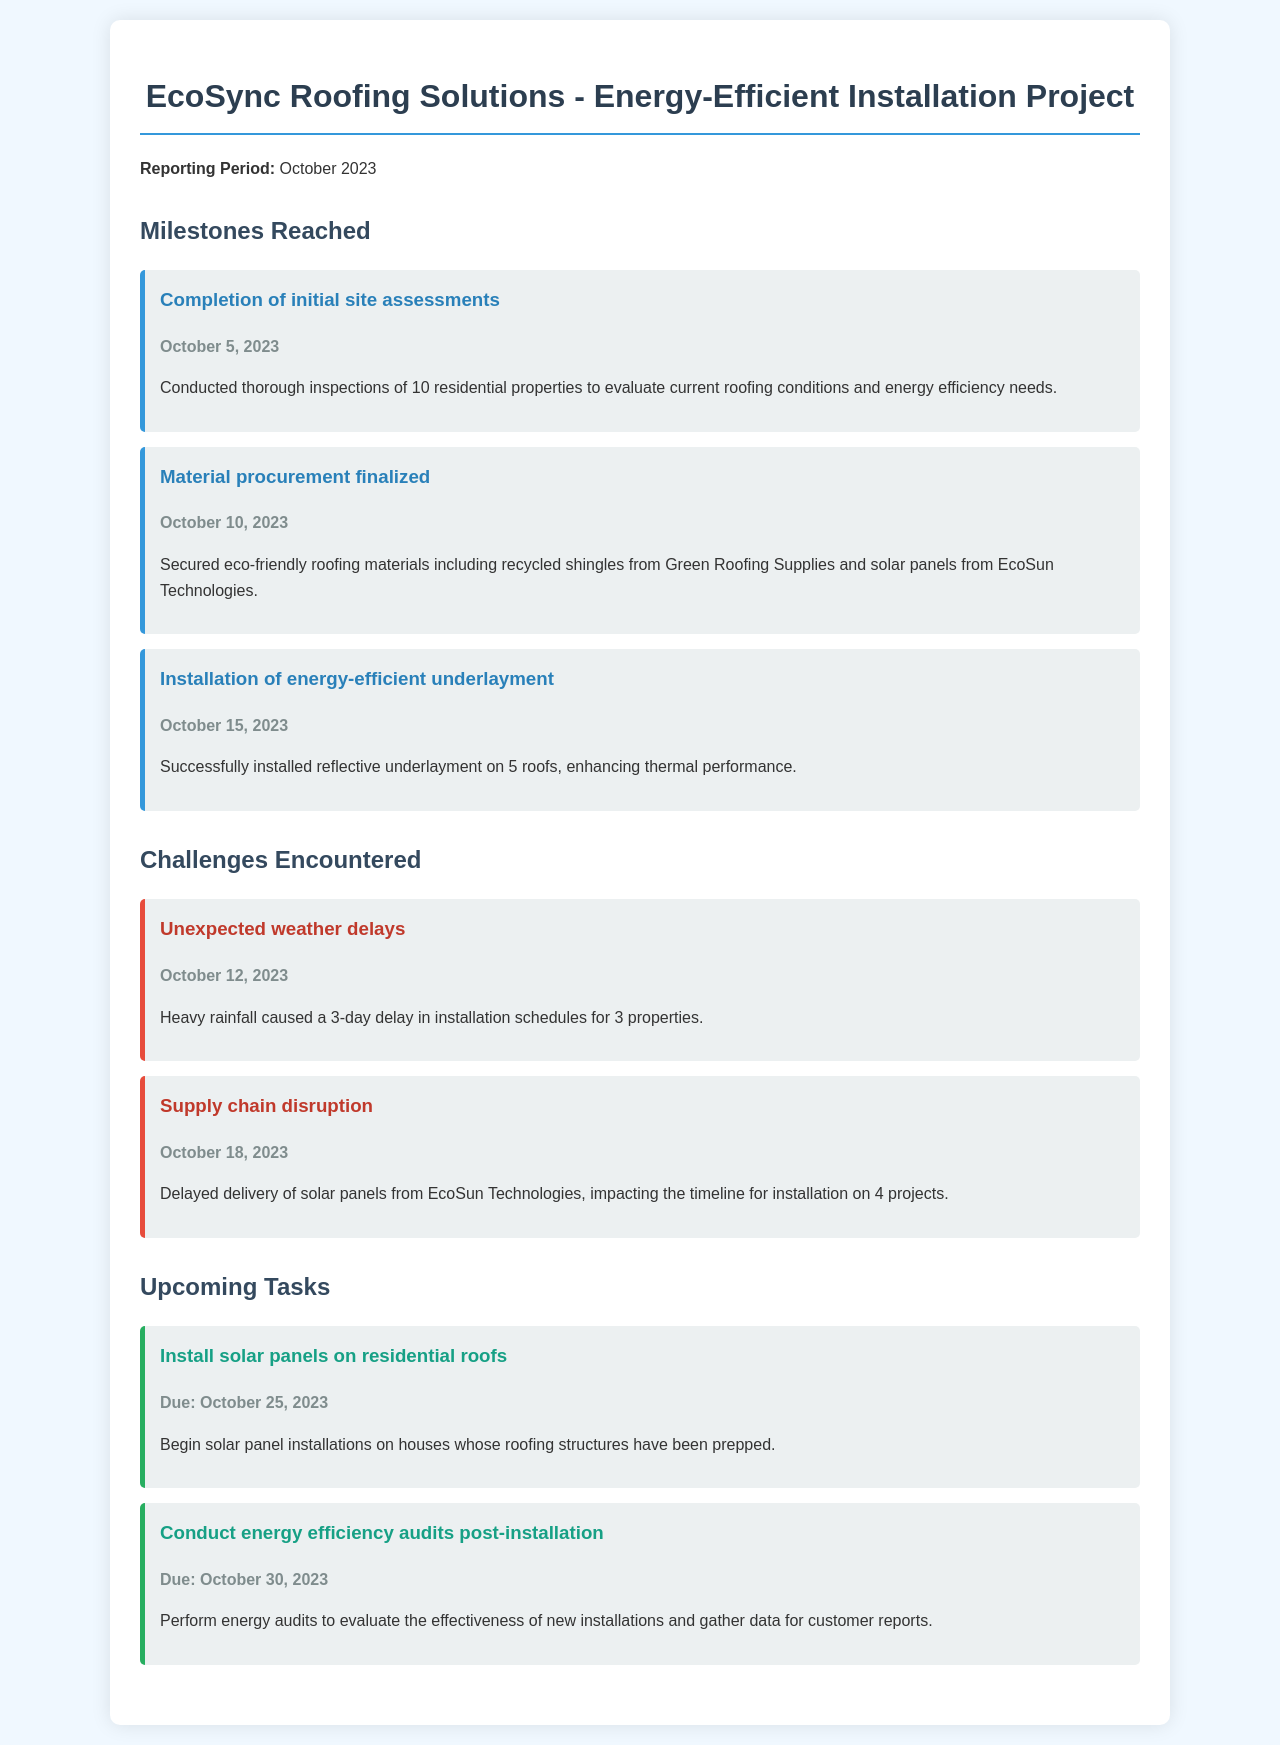What is the reporting period? The reporting period is specified in the document as October 2023.
Answer: October 2023 How many residential properties were inspected? The document states that inspections were conducted on 10 residential properties.
Answer: 10 What material was secured from Green Roofing Supplies? The document mentions that recycled shingles were procured from Green Roofing Supplies.
Answer: Recycled shingles What challenge caused a 3-day delay? The document notes that heavy rainfall caused a 3-day delay in installation schedules.
Answer: Heavy rainfall What is the due date for solar panel installations? The document provides a due date for solar panel installations as October 25, 2023.
Answer: October 25, 2023 How many roofs had the energy-efficient underlayment installed? According to the document, reflective underlayment was installed on 5 roofs.
Answer: 5 roofs What is the nature of the upcoming task on October 30, 2023? The upcoming task on October 30, 2023, is to conduct energy efficiency audits post-installation.
Answer: Conduct energy efficiency audits What item was delayed due to a supply chain disruption? The document specifically mentions that the delivery of solar panels was delayed.
Answer: Solar panels What percentage of the projects were affected by the supply chain disruption? The document states that 4 projects were impacted by the delayed delivery of solar panels. Since the total projects are not stated, we cannot determine the percentage.
Answer: Not applicable 